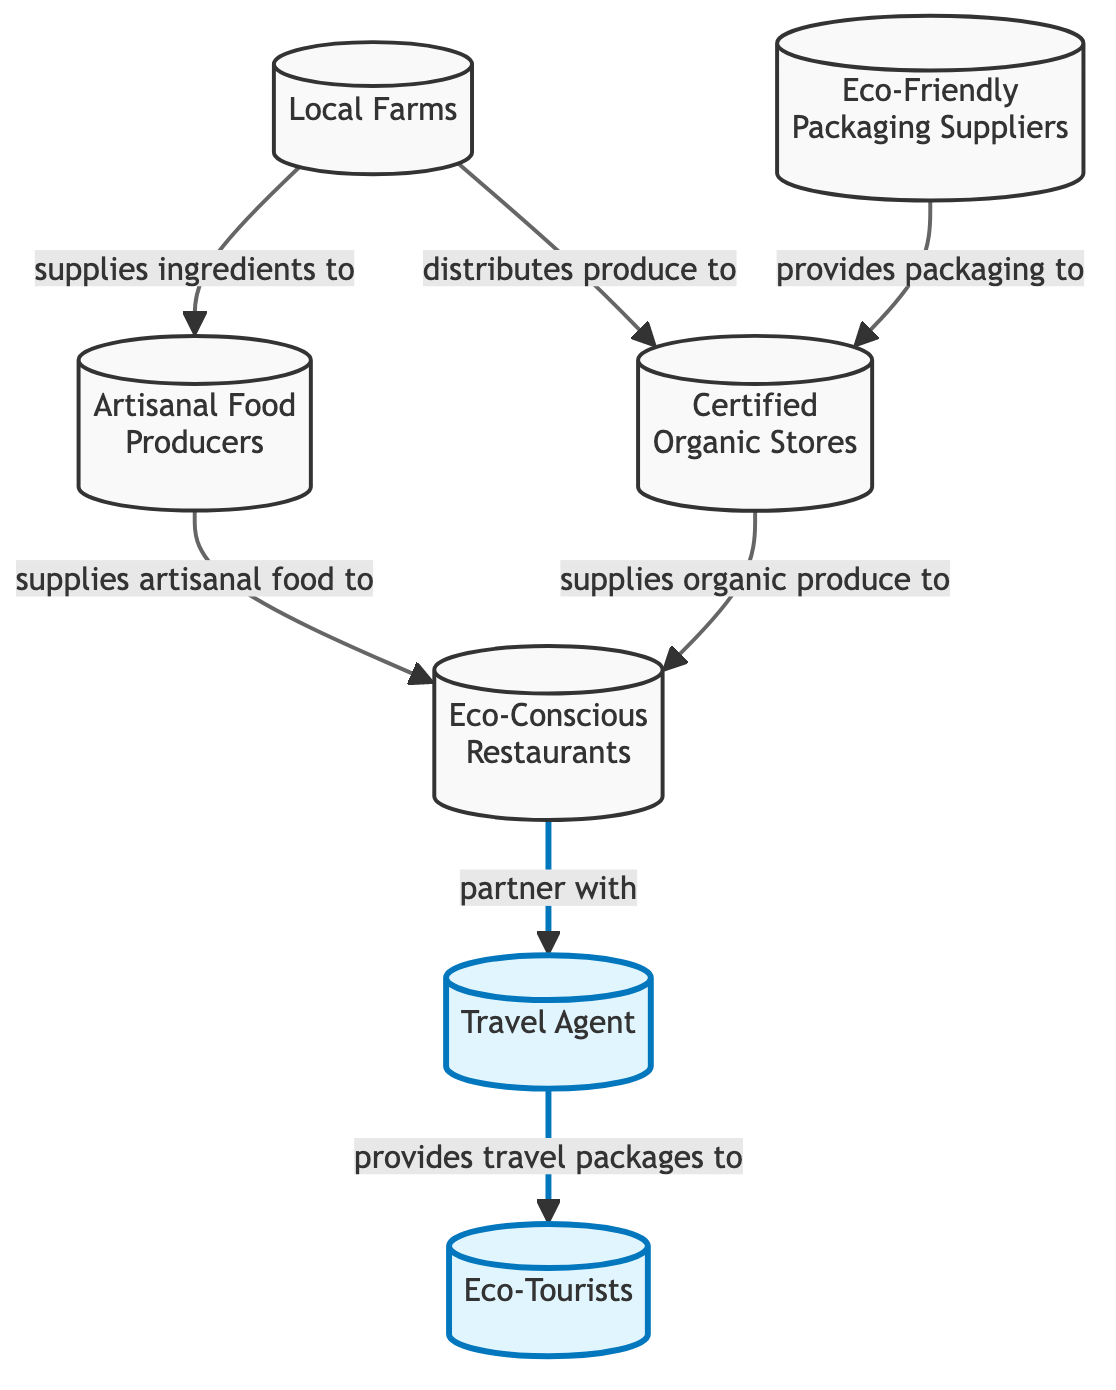What is the starting point of the food chain? The food chain begins with local farms, which play a crucial role in supplying the basic ingredients necessary for further production.
Answer: Local Farms How many nodes are present in the diagram? The diagram contains a total of seven distinct nodes, representing different entities involved in sustainable food sourcing.
Answer: 7 Which node directly supplies ingredients to artisanal food producers? Local farms provide the foundational ingredients that artisanal food producers use to create their products.
Answer: Local Farms What type of stores receive produce from local farms? Certified organic stores are identified as the type of stores that receive produce directly from local farms, emphasizing the organic quality of the products.
Answer: Certified Organic Stores Who partners with eco-friendly restaurants in this food chain? Eco-conscious restaurants are established partners with the travel agent, indicating a collaboration to promote sustainable practices in travel packages.
Answer: Travel Agent What serves as a supplier for eco-friendly packaging? Eco-friendly packaging suppliers are responsible for providing sustainable packaging solutions to certified organic stores, ensuring that the packaging aligns with eco-conscious practices.
Answer: Eco-Friendly Packaging Suppliers Trace the supply chain: Who provides artisanal food to eco-friendly restaurants? Artisanal food producers are the ones supplying their crafted foods to eco-friendly restaurants, showing the direct flow of goods from production to consumption.
Answer: Artisanal Food Producers What is the role of eco-tourists in this diagram? Eco-tourists are the end-users who receive travel packages from the travel agent, thus representing the consumer end of the sustainable tourism market.
Answer: Eco-Tourists How do eco-friendly restaurants obtain organic produce? Eco-friendly restaurants receive organic produce from certified organic stores, which indicates a sourcing relationship centered on organic offerings.
Answer: Certified Organic Stores 